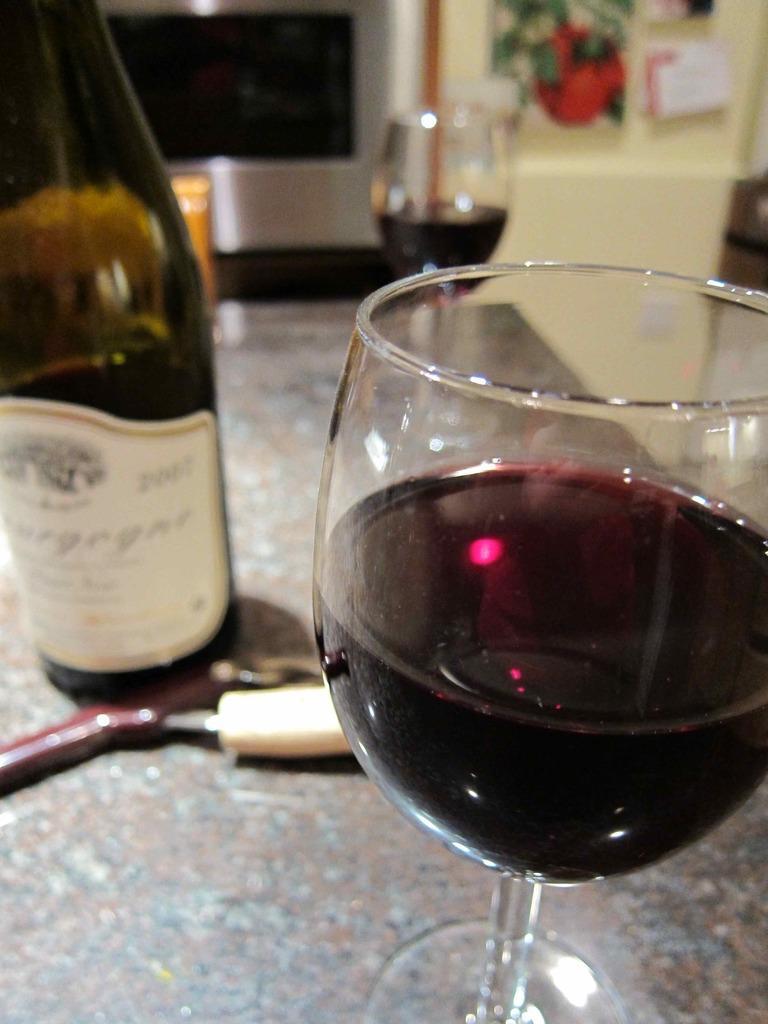Can you describe this image briefly? in this picture there is a bottle and two glasses on the table. There is wine in the glasses. On the bottle there is label sticked. There is door in the background and its blurred. 